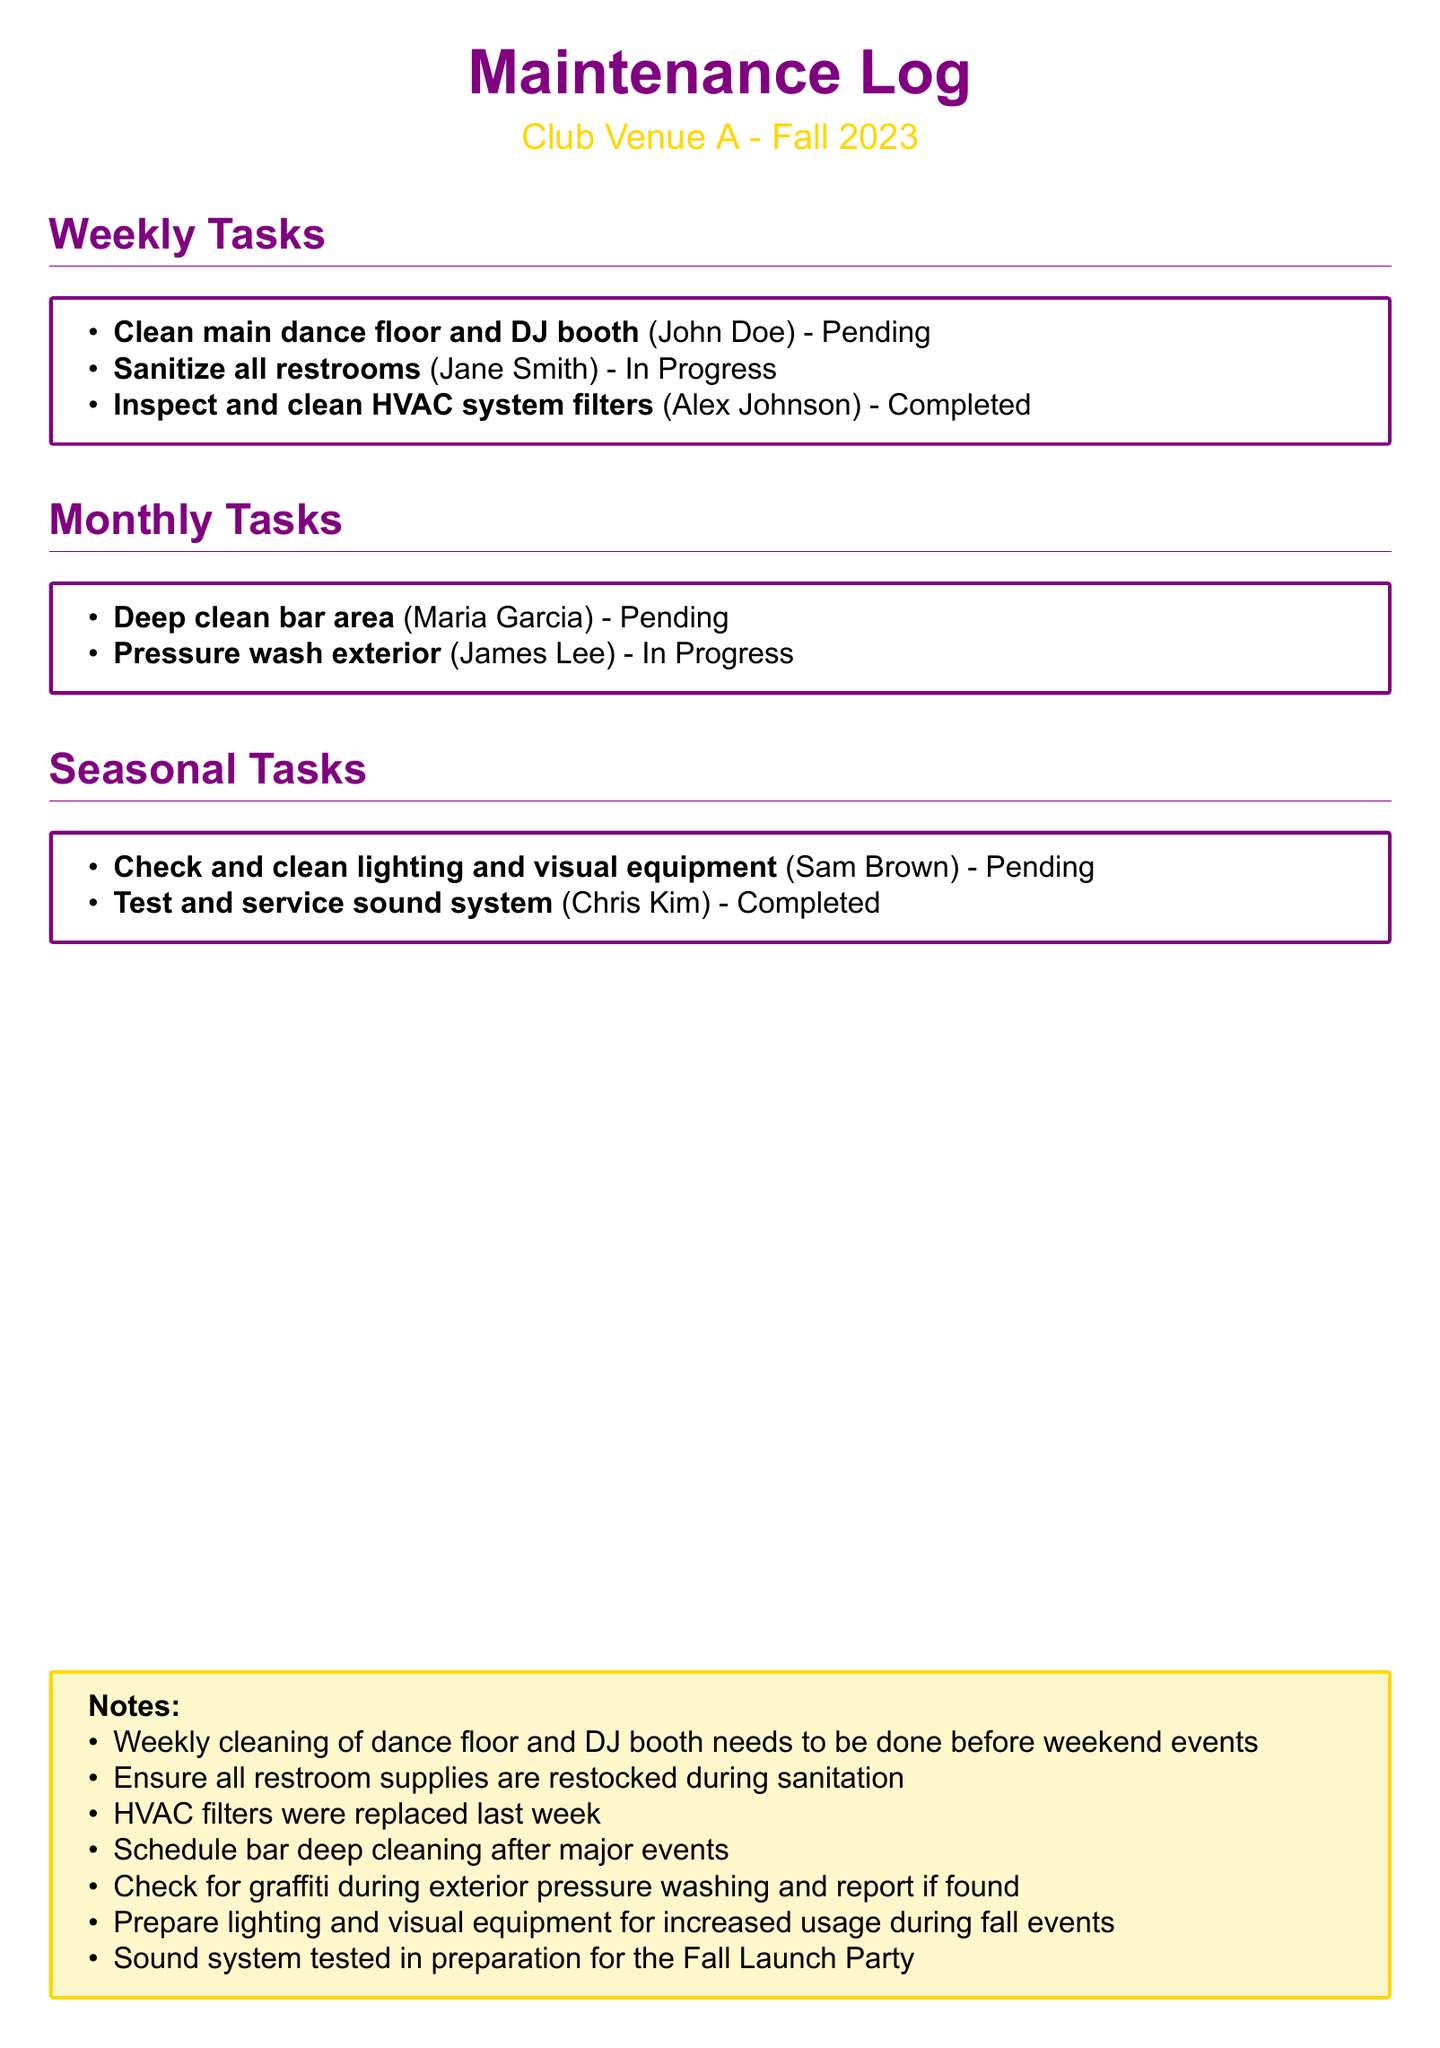What is the status of cleaning the main dance floor and DJ booth? The same task is listed as "Pending" in the weekly tasks section.
Answer: Pending Who is responsible for sanitizing all restrooms? The name listed next to this task in the weekly tasks section is "Jane Smith."
Answer: Jane Smith When was the HVAC system filters inspection and cleaning completed? The document states that this task is marked as "Completed."
Answer: Completed Which task is pending under monthly tasks? The document lists "Deep clean bar area" as pending in the monthly tasks section.
Answer: Deep clean bar area How many tasks are assigned to personnel in the seasonal tasks section? There are two tasks listed in the seasonal tasks section, each assigned to a different individual.
Answer: 2 What specific maintenance action is noted for the sound system? The document states that the "Sound system tested in preparation for the Fall Launch Party" in the notes section.
Answer: Tested Which area is scheduled for pressure washing? The document notes that the "exterior" is to be pressure washed in the monthly tasks section.
Answer: Exterior Who is in charge of checking and cleaning the lighting and visual equipment? The task is assigned to "Sam Brown" in the seasonal tasks section.
Answer: Sam Brown What was done last week regarding HVAC filters? The notes mention that "HVAC filters were replaced last week."
Answer: Replaced 